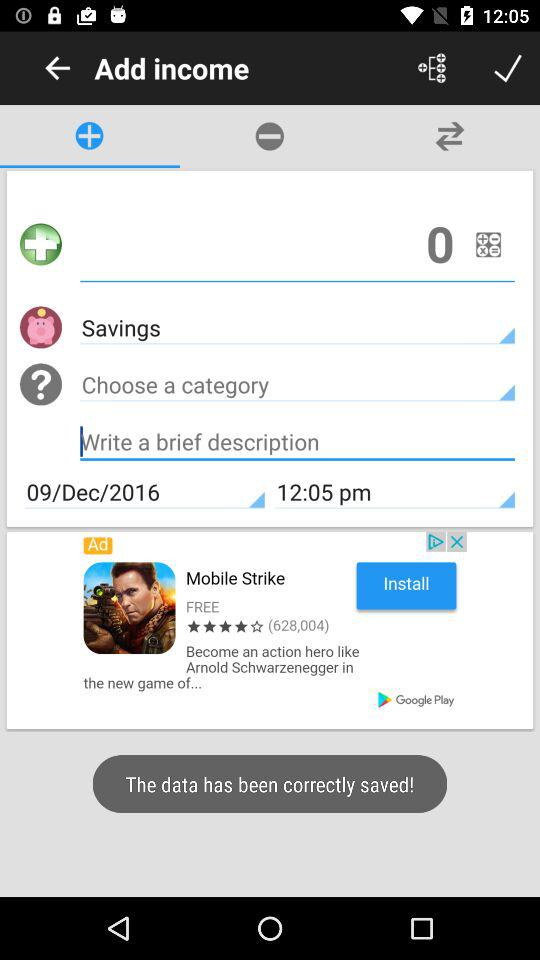What is the mentioned time? The time is 12:05 pm. 